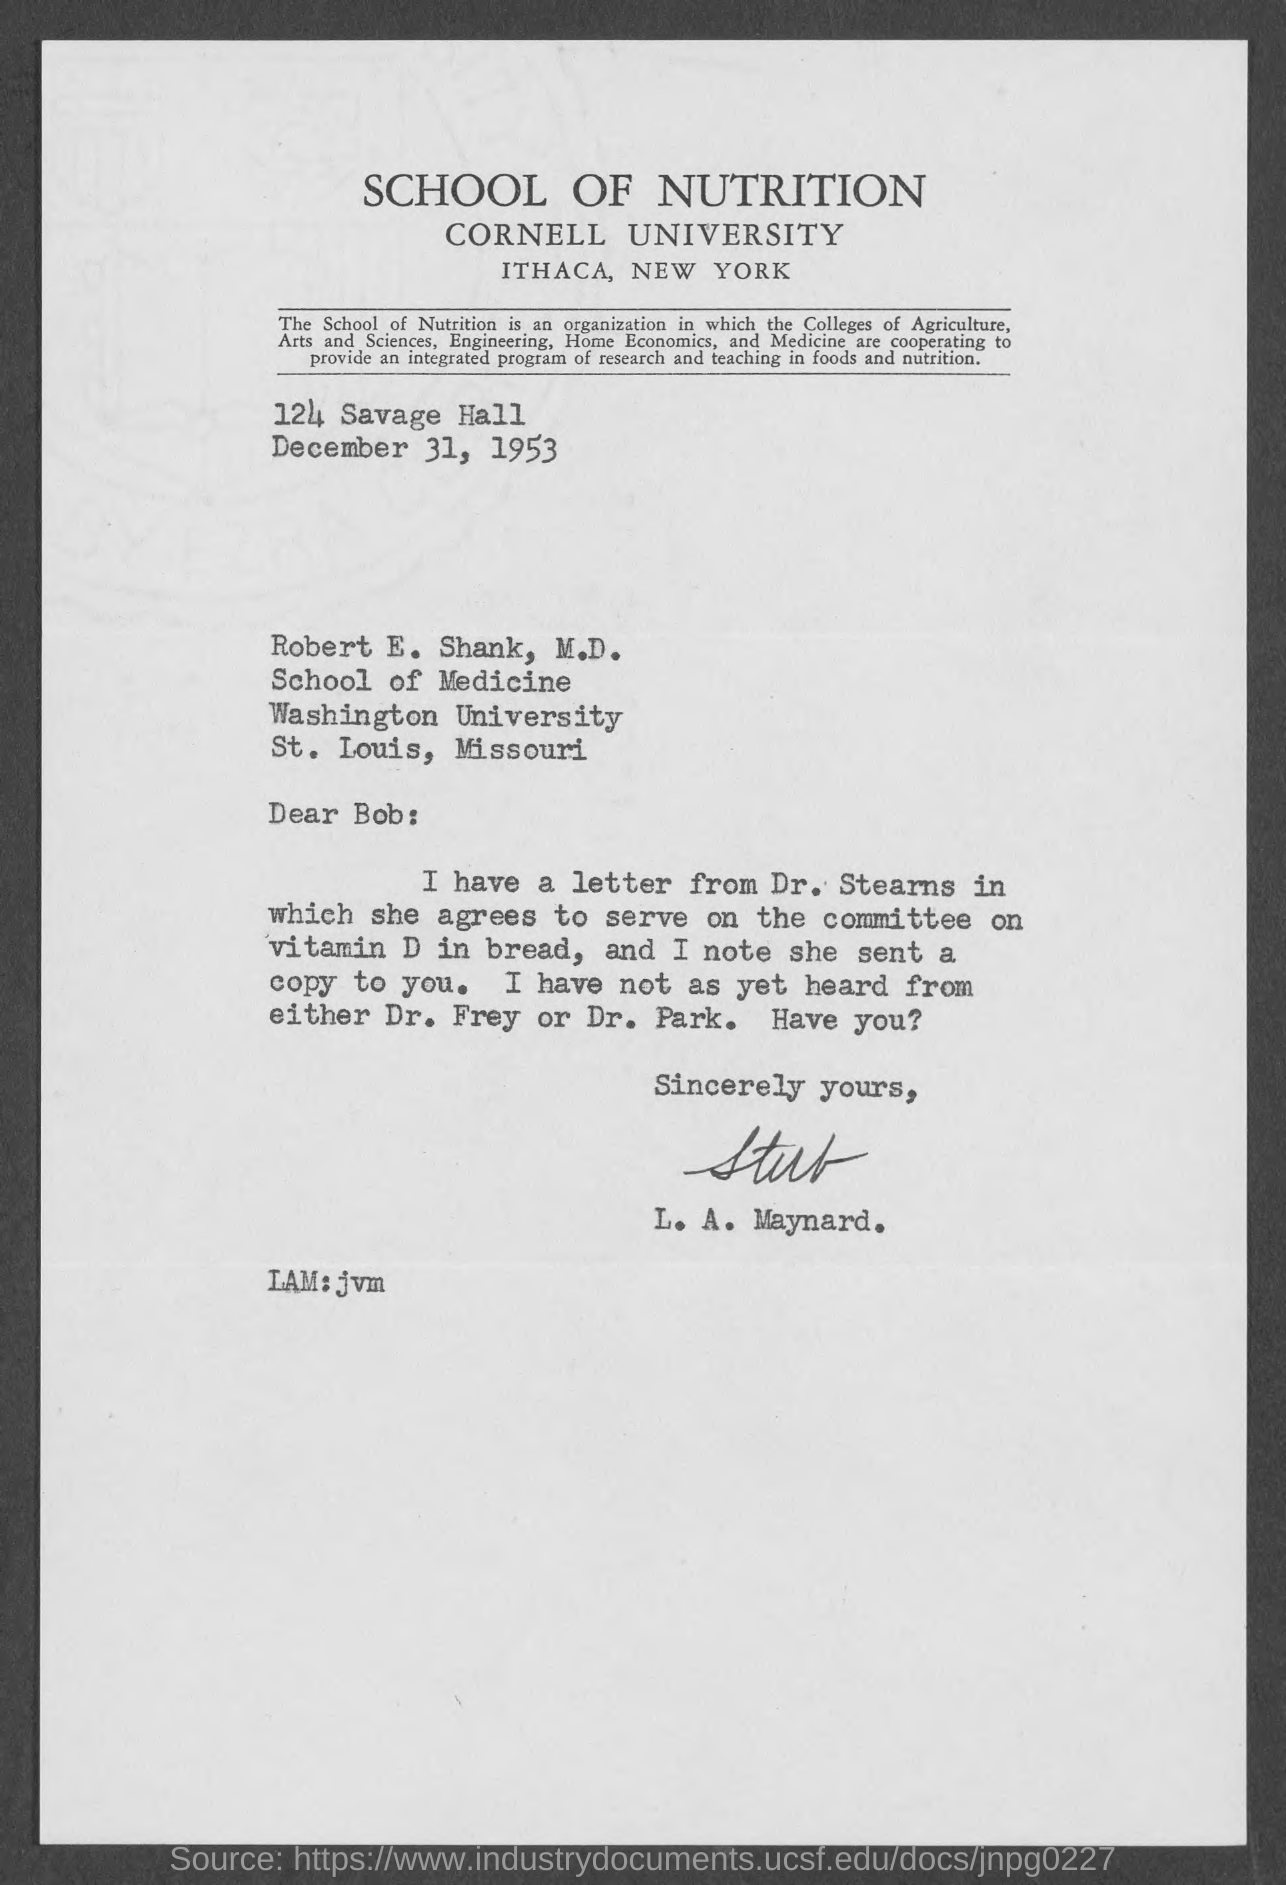Outline some significant characteristics in this image. The Memorandum was dated on December 31, 1953. 